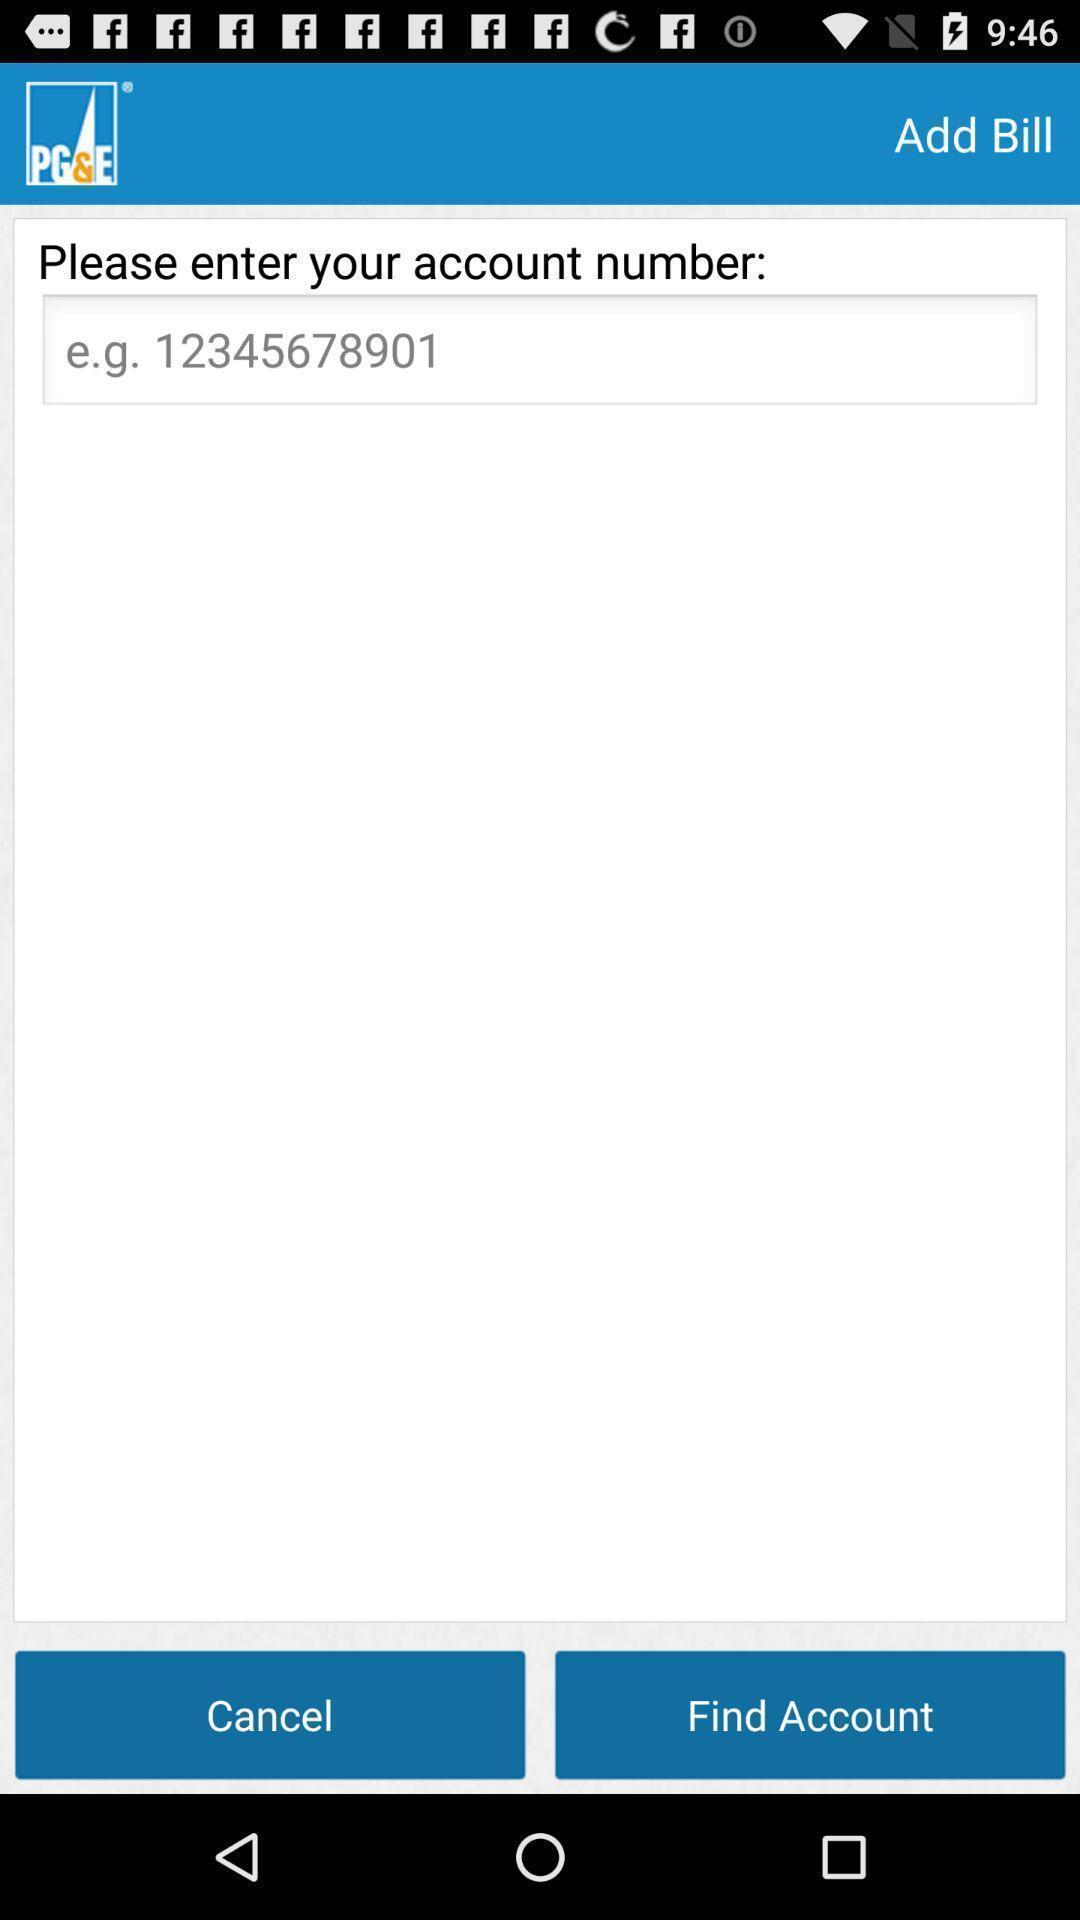Summarize the information in this screenshot. Page displayed to enter account number on payment app. 